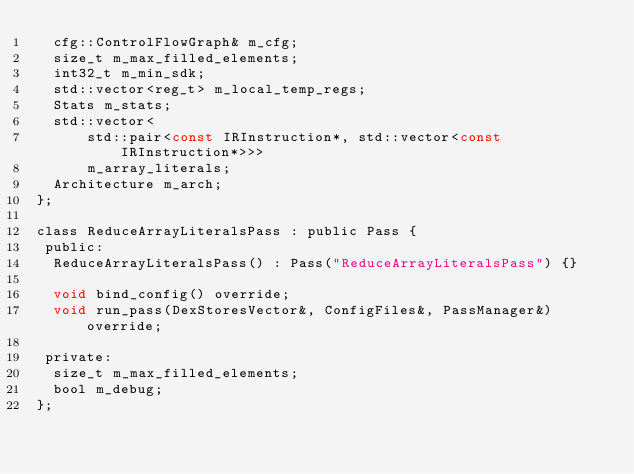<code> <loc_0><loc_0><loc_500><loc_500><_C_>  cfg::ControlFlowGraph& m_cfg;
  size_t m_max_filled_elements;
  int32_t m_min_sdk;
  std::vector<reg_t> m_local_temp_regs;
  Stats m_stats;
  std::vector<
      std::pair<const IRInstruction*, std::vector<const IRInstruction*>>>
      m_array_literals;
  Architecture m_arch;
};

class ReduceArrayLiteralsPass : public Pass {
 public:
  ReduceArrayLiteralsPass() : Pass("ReduceArrayLiteralsPass") {}

  void bind_config() override;
  void run_pass(DexStoresVector&, ConfigFiles&, PassManager&) override;

 private:
  size_t m_max_filled_elements;
  bool m_debug;
};
</code> 